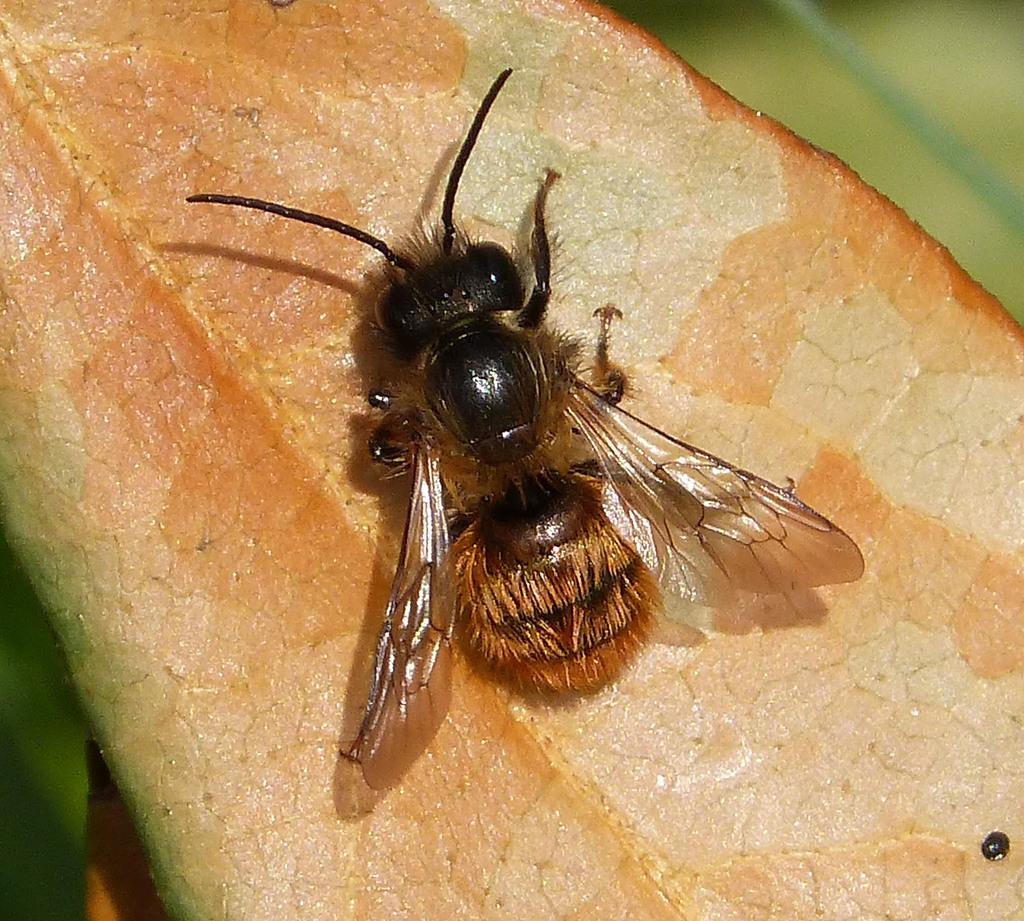What is present on the leaf in the image? There is a fly on the leaf in the image. What can be inferred about the leaf's condition? The leaf appears to be dried, and it is in brown color. Are the sisters discussing payment for the fly in the image? There are no sisters or discussion about payment in the image; it only features a fly on a dried, brown leaf. 